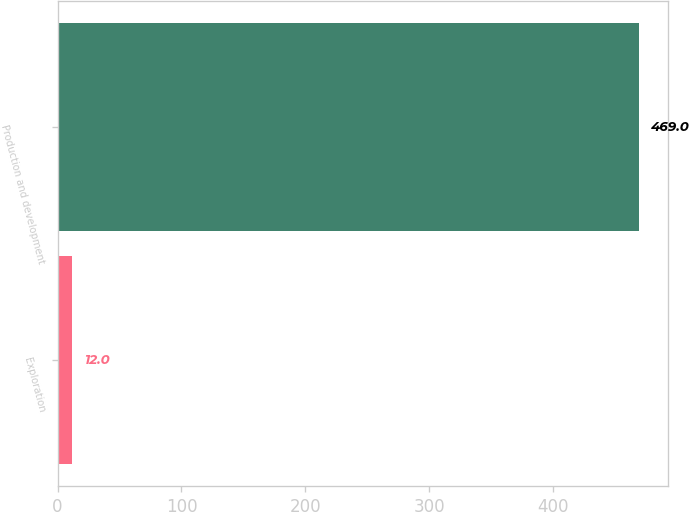Convert chart. <chart><loc_0><loc_0><loc_500><loc_500><bar_chart><fcel>Exploration<fcel>Production and development<nl><fcel>12<fcel>469<nl></chart> 